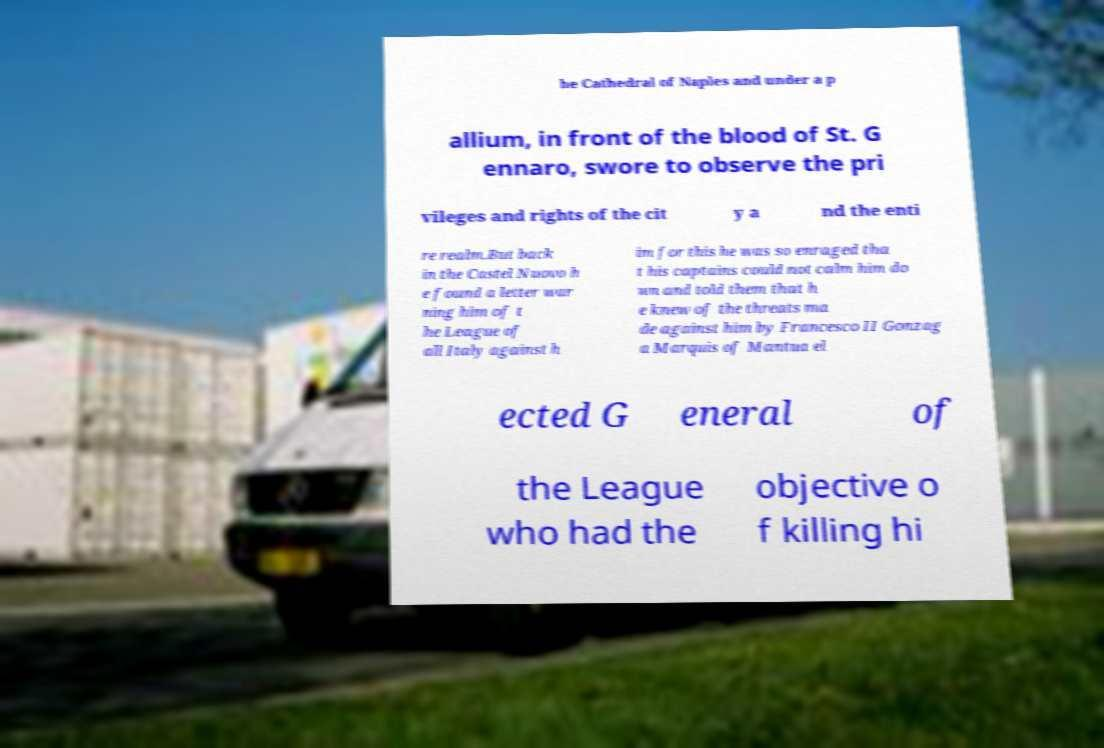Please identify and transcribe the text found in this image. he Cathedral of Naples and under a p allium, in front of the blood of St. G ennaro, swore to observe the pri vileges and rights of the cit y a nd the enti re realm.But back in the Castel Nuovo h e found a letter war ning him of t he League of all Italy against h im for this he was so enraged tha t his captains could not calm him do wn and told them that h e knew of the threats ma de against him by Francesco II Gonzag a Marquis of Mantua el ected G eneral of the League who had the objective o f killing hi 